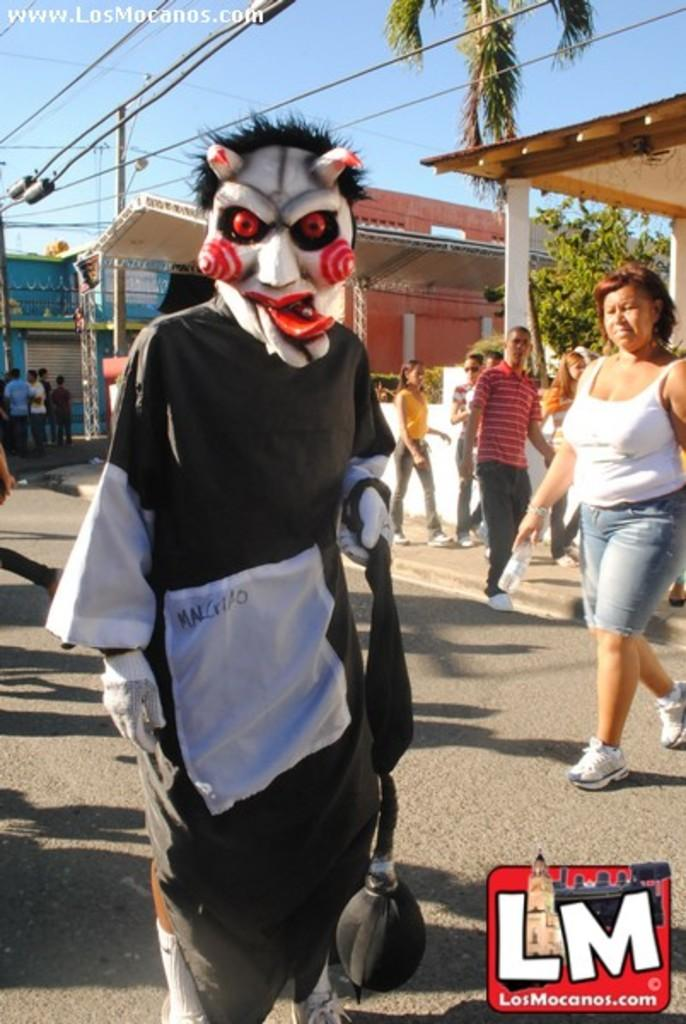What is the person in the image wearing on their face? The person in the image is wearing a mask. Can you describe the surroundings of the person in the image? There are people and buildings in the background of the image, as well as trees. What is the price of the shoes worn by the expert in the image? There is no expert or shoes present in the image, so it is not possible to determine the price of any shoes. 